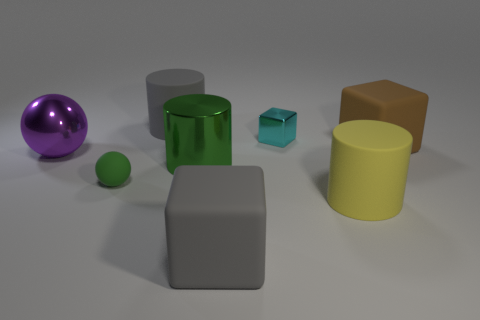Imagine this is a scene from a science fiction film. What could these objects represent? In a science fiction context, these objects might represent a collection of intergalactic artifacts with unique properties. The purple sphere could be a power source pulsing with unknown energy. The green and yellow cylinders might be containers for rare extraterrestrial materials. The blue cube could be an alien technology module, and the small green sphere could serve as a key to activate a portal or device. The gray matte and brown cubes could be weights or stands designed to hold the powerful artifacts in place aboard a spacecraft's laboratory. 